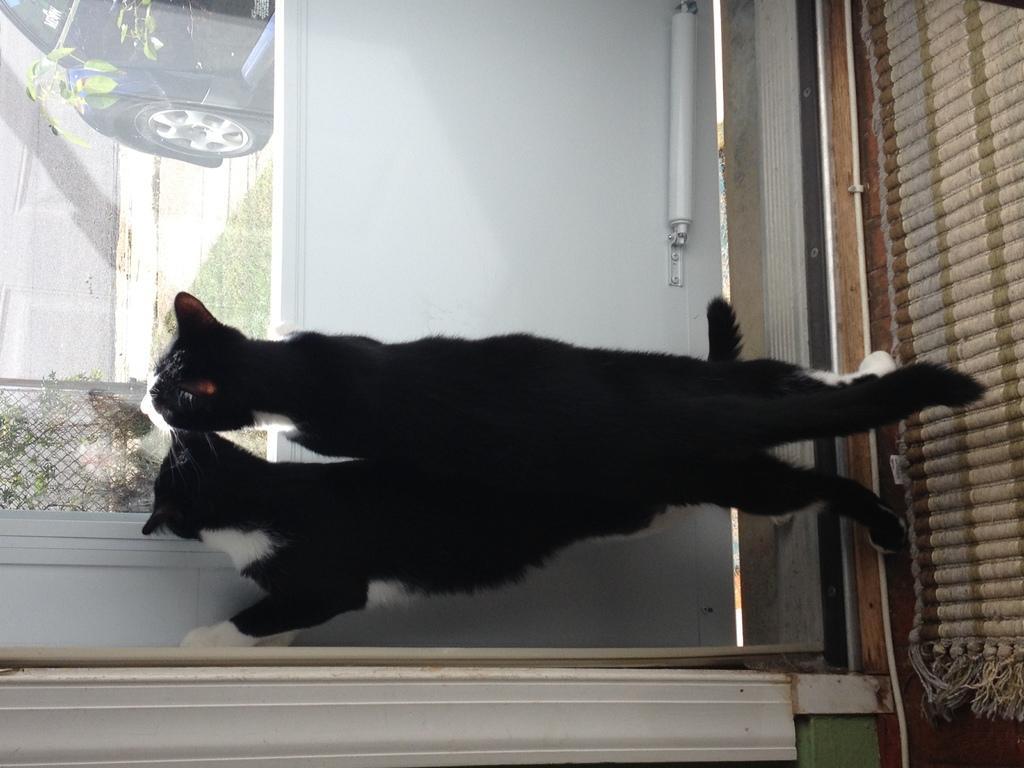How would you summarize this image in a sentence or two? In the foreground I can see two cats, glass window, fence, grass, vehicle on the road and wall. This image is taken may be in a room. 